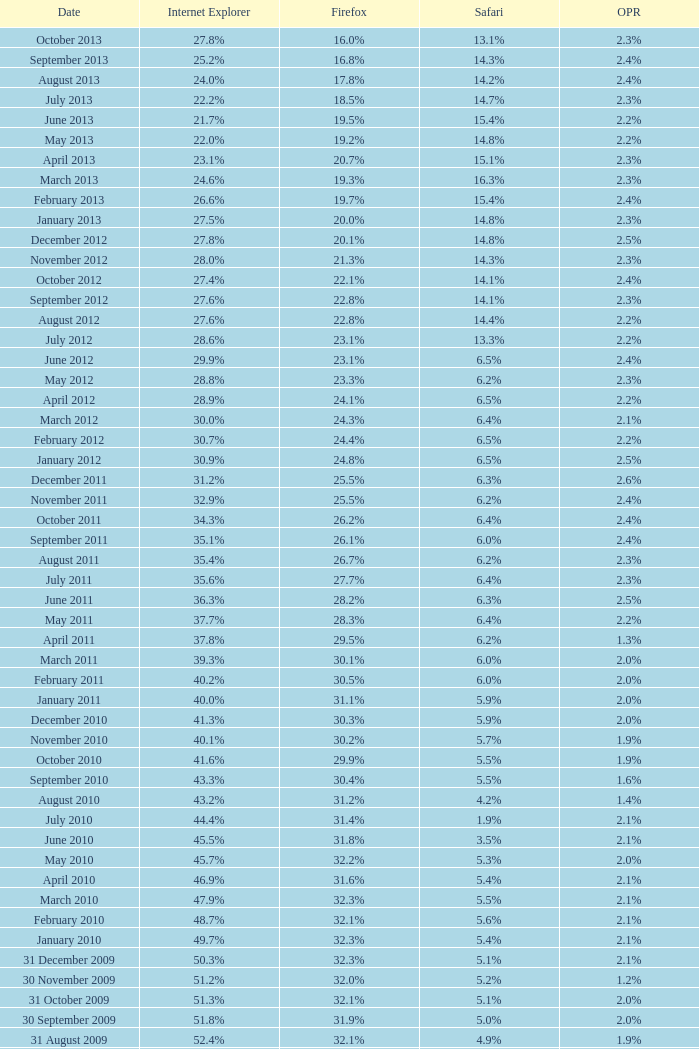What is the safari value with a 28.0% internet explorer? 14.3%. 